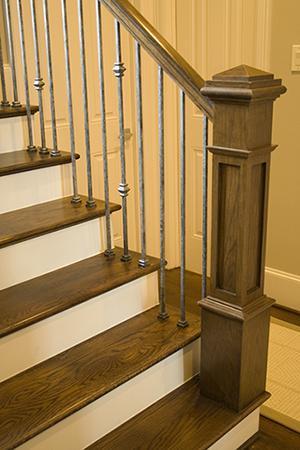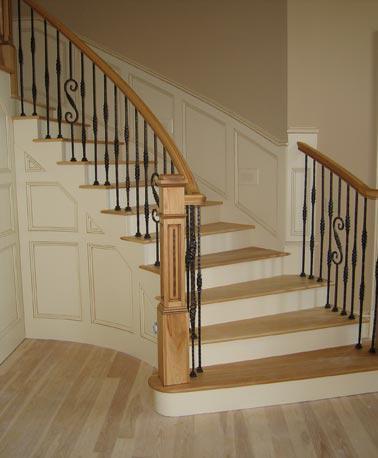The first image is the image on the left, the second image is the image on the right. Evaluate the accuracy of this statement regarding the images: "The right image shows a curved staircase with a brown wood handrail and black wrought iron bars with a scroll embellishment.". Is it true? Answer yes or no. Yes. The first image is the image on the left, the second image is the image on the right. Given the left and right images, does the statement "The staircase in the image on the right winds down in a circular fashion." hold true? Answer yes or no. Yes. 